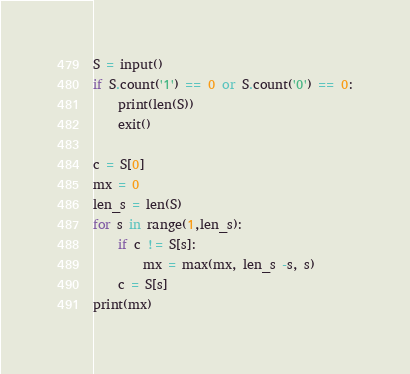<code> <loc_0><loc_0><loc_500><loc_500><_Python_>S = input()
if S.count('1') == 0 or S.count('0') == 0:
    print(len(S))
    exit()

c = S[0]
mx = 0
len_s = len(S)
for s in range(1,len_s):
    if c != S[s]:
        mx = max(mx, len_s -s, s)
    c = S[s]
print(mx)
</code> 